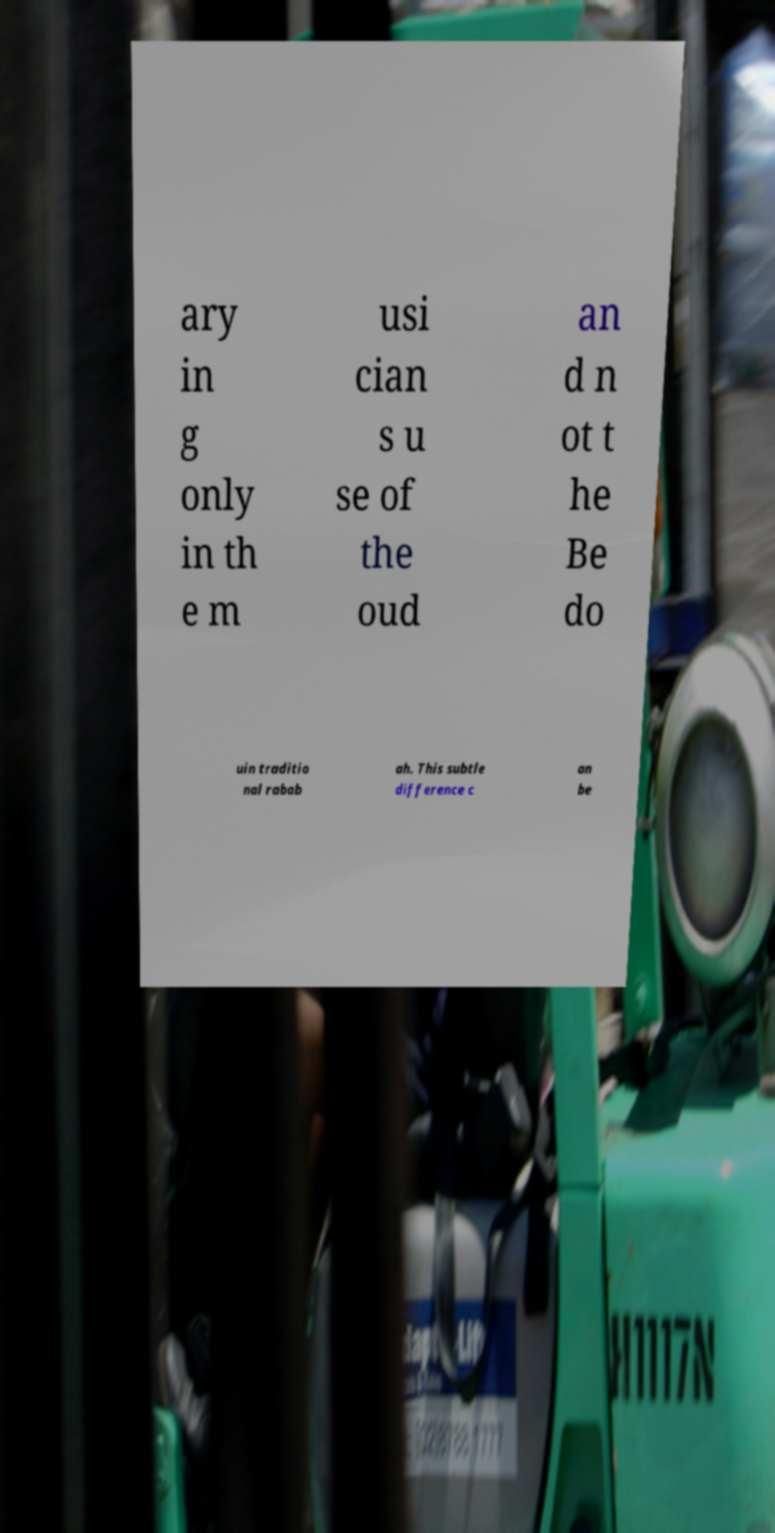Can you read and provide the text displayed in the image?This photo seems to have some interesting text. Can you extract and type it out for me? ary in g only in th e m usi cian s u se of the oud an d n ot t he Be do uin traditio nal rabab ah. This subtle difference c an be 